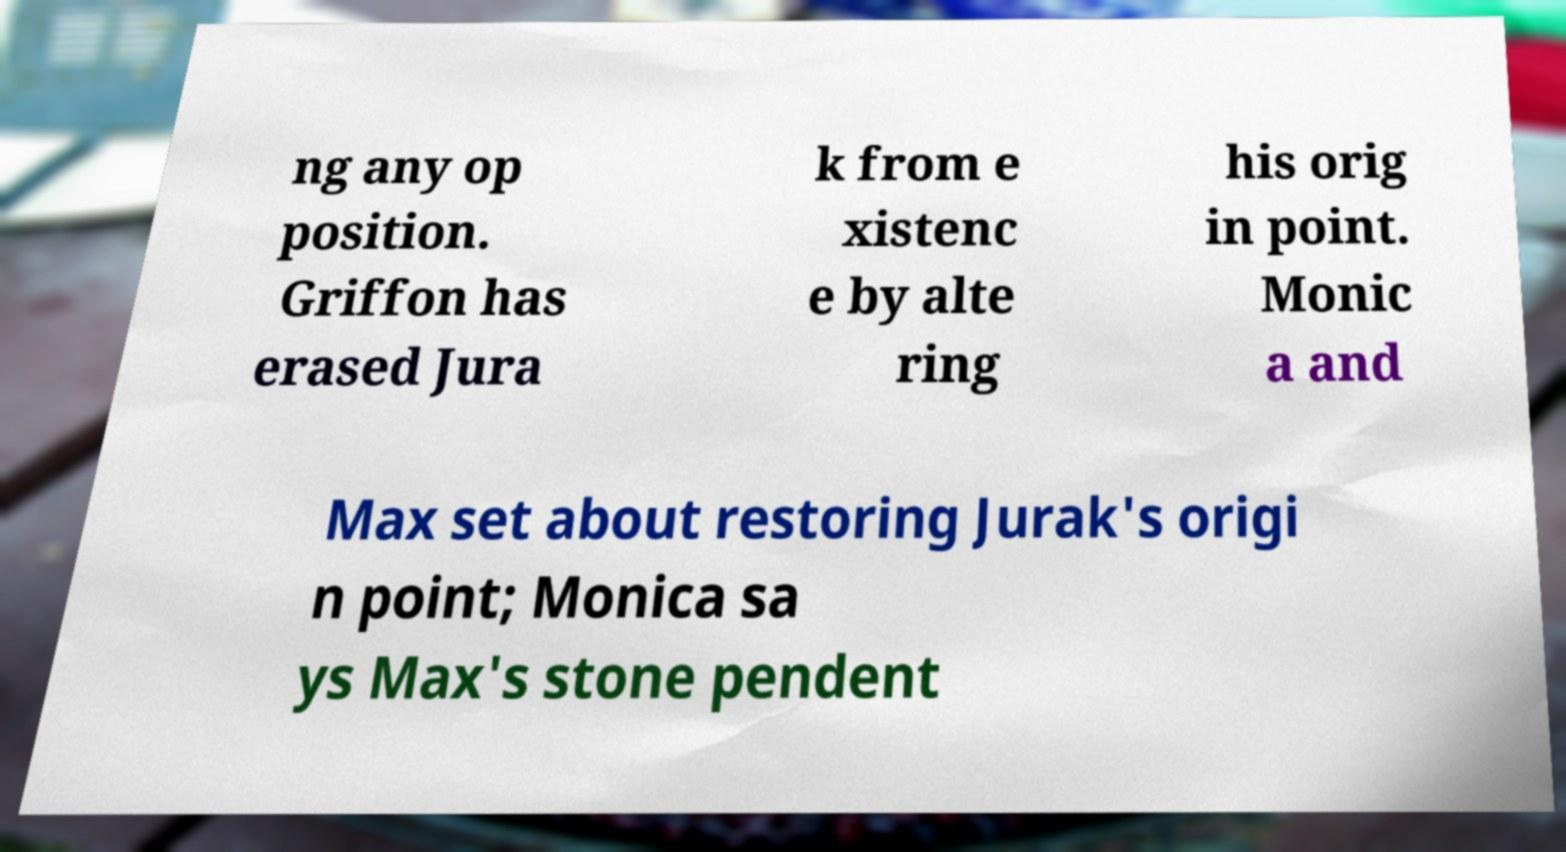For documentation purposes, I need the text within this image transcribed. Could you provide that? ng any op position. Griffon has erased Jura k from e xistenc e by alte ring his orig in point. Monic a and Max set about restoring Jurak's origi n point; Monica sa ys Max's stone pendent 